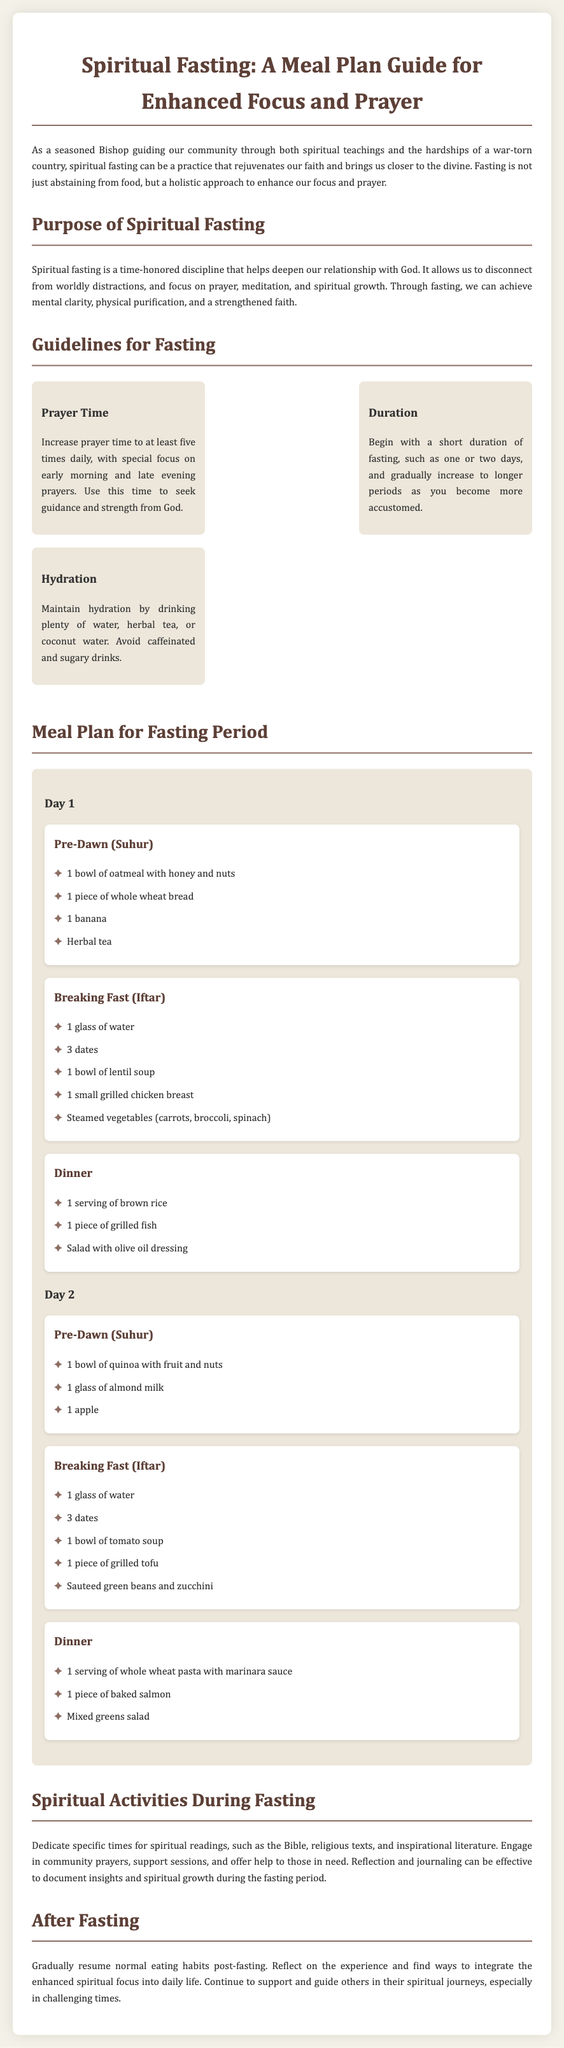What is the title of the document? The title of the document is stated prominently at the top, indicating the subject matter it covers.
Answer: Spiritual Fasting: A Meal Plan Guide for Enhanced Focus and Prayer How many days does the meal plan cover? The document includes a meal plan with specific details for two days.
Answer: 2 days What is suggested for hydration during fasting? The guidelines specifically mention what drinks to maintain hydration during the fasting period.
Answer: Water, herbal tea, or coconut water What is the first meal on Day 1 called? The meal plan specifies the name of the pre-dawn meal at the beginning of Day 1.
Answer: Pre-Dawn (Suhur) What is the main protein source in the Iftar meal on Day 1? The meal plan details the main protein source provided during the Iftar meal on Day 1.
Answer: Grilled chicken breast How many times daily should prayer time be increased? The guidelines specify a specific frequency for prayer during the fasting period.
Answer: Five times daily What activity is encouraged during fasting besides eating? The document lists spiritual activities in addition to the meal plan, emphasizing engagement beyond food.
Answer: Spiritual readings When should one begin fasting according to the guidelines? The document recommends starting with a particular duration for fasting.
Answer: One or two days What type of soup is served during Iftar on Day 2? The meal plan explicitly states the type of soup provided during the Iftar meal on Day 2.
Answer: Tomato soup 